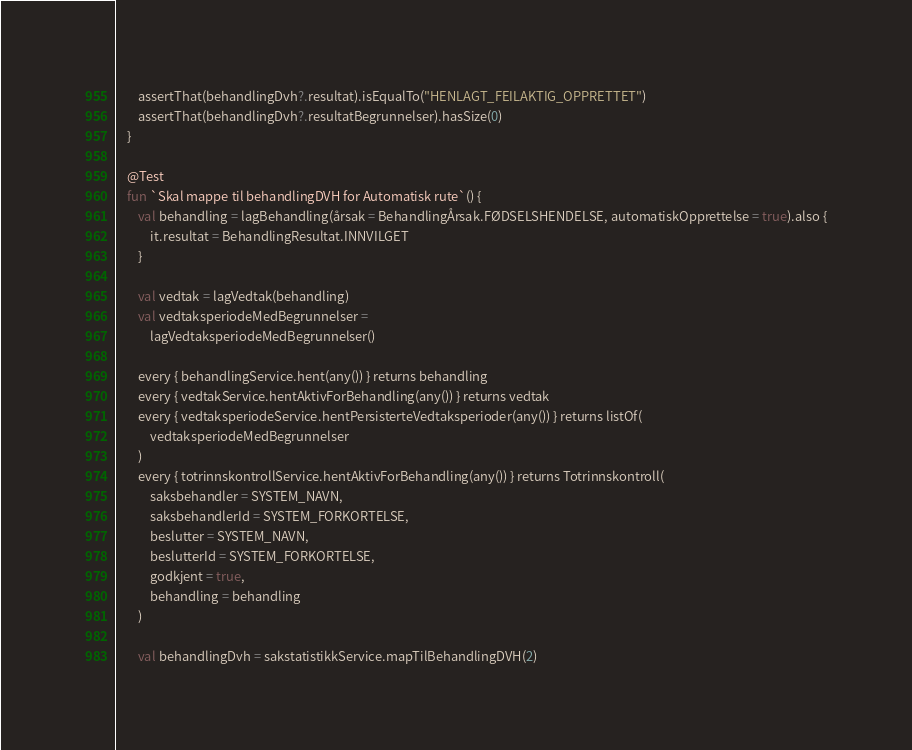Convert code to text. <code><loc_0><loc_0><loc_500><loc_500><_Kotlin_>
        assertThat(behandlingDvh?.resultat).isEqualTo("HENLAGT_FEILAKTIG_OPPRETTET")
        assertThat(behandlingDvh?.resultatBegrunnelser).hasSize(0)
    }

    @Test
    fun `Skal mappe til behandlingDVH for Automatisk rute`() {
        val behandling = lagBehandling(årsak = BehandlingÅrsak.FØDSELSHENDELSE, automatiskOpprettelse = true).also {
            it.resultat = BehandlingResultat.INNVILGET
        }

        val vedtak = lagVedtak(behandling)
        val vedtaksperiodeMedBegrunnelser =
            lagVedtaksperiodeMedBegrunnelser()

        every { behandlingService.hent(any()) } returns behandling
        every { vedtakService.hentAktivForBehandling(any()) } returns vedtak
        every { vedtaksperiodeService.hentPersisterteVedtaksperioder(any()) } returns listOf(
            vedtaksperiodeMedBegrunnelser
        )
        every { totrinnskontrollService.hentAktivForBehandling(any()) } returns Totrinnskontroll(
            saksbehandler = SYSTEM_NAVN,
            saksbehandlerId = SYSTEM_FORKORTELSE,
            beslutter = SYSTEM_NAVN,
            beslutterId = SYSTEM_FORKORTELSE,
            godkjent = true,
            behandling = behandling
        )

        val behandlingDvh = sakstatistikkService.mapTilBehandlingDVH(2)</code> 